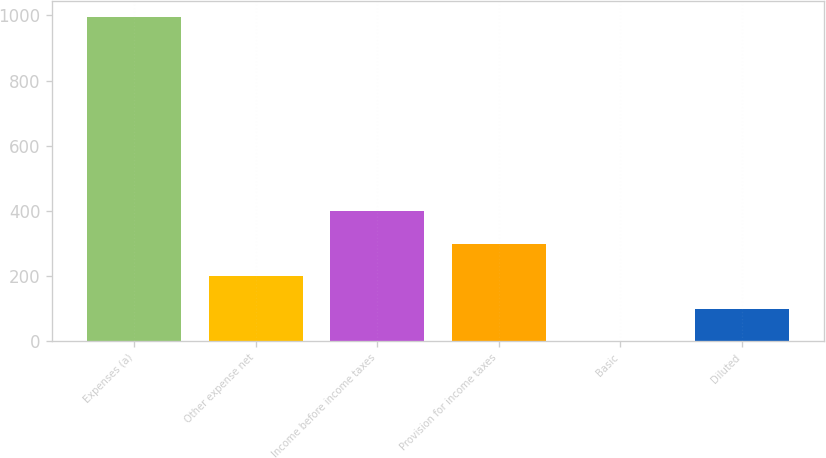<chart> <loc_0><loc_0><loc_500><loc_500><bar_chart><fcel>Expenses (a)<fcel>Other expense net<fcel>Income before income taxes<fcel>Provision for income taxes<fcel>Basic<fcel>Diluted<nl><fcel>995.4<fcel>199.34<fcel>398.36<fcel>298.85<fcel>0.32<fcel>99.83<nl></chart> 